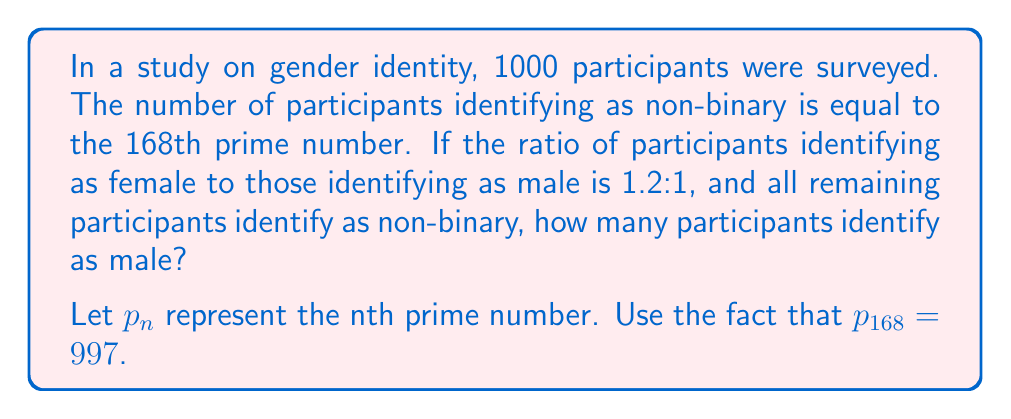Show me your answer to this math problem. Let's approach this step-by-step:

1) First, we know that the number of non-binary participants is equal to the 168th prime number.
   $p_{168} = 997$

2) Let's define variables:
   $x$ = number of male participants
   $1.2x$ = number of female participants (given the 1.2:1 ratio)
   $997$ = number of non-binary participants

3) We know the total number of participants is 1000, so we can set up an equation:

   $x + 1.2x + 997 = 1000$

4) Simplify the left side of the equation:

   $2.2x + 997 = 1000$

5) Subtract 997 from both sides:

   $2.2x = 3$

6) Divide both sides by 2.2:

   $x = \frac{3}{2.2} = \frac{30}{22} \approx 1.3636$

7) Since we're dealing with whole numbers of people, we need to round to the nearest integer:

   $x = 1$ (rounded down)

8) Let's verify:
   Male participants: 1
   Female participants: $1.2 * 1 = 1.2$ (rounds to 1)
   Non-binary participants: 997
   Total: $1 + 1 + 997 = 999$

   This is the closest we can get to 1000 while maintaining the given ratio and prime number constraint.
Answer: 1 participant identifies as male. 